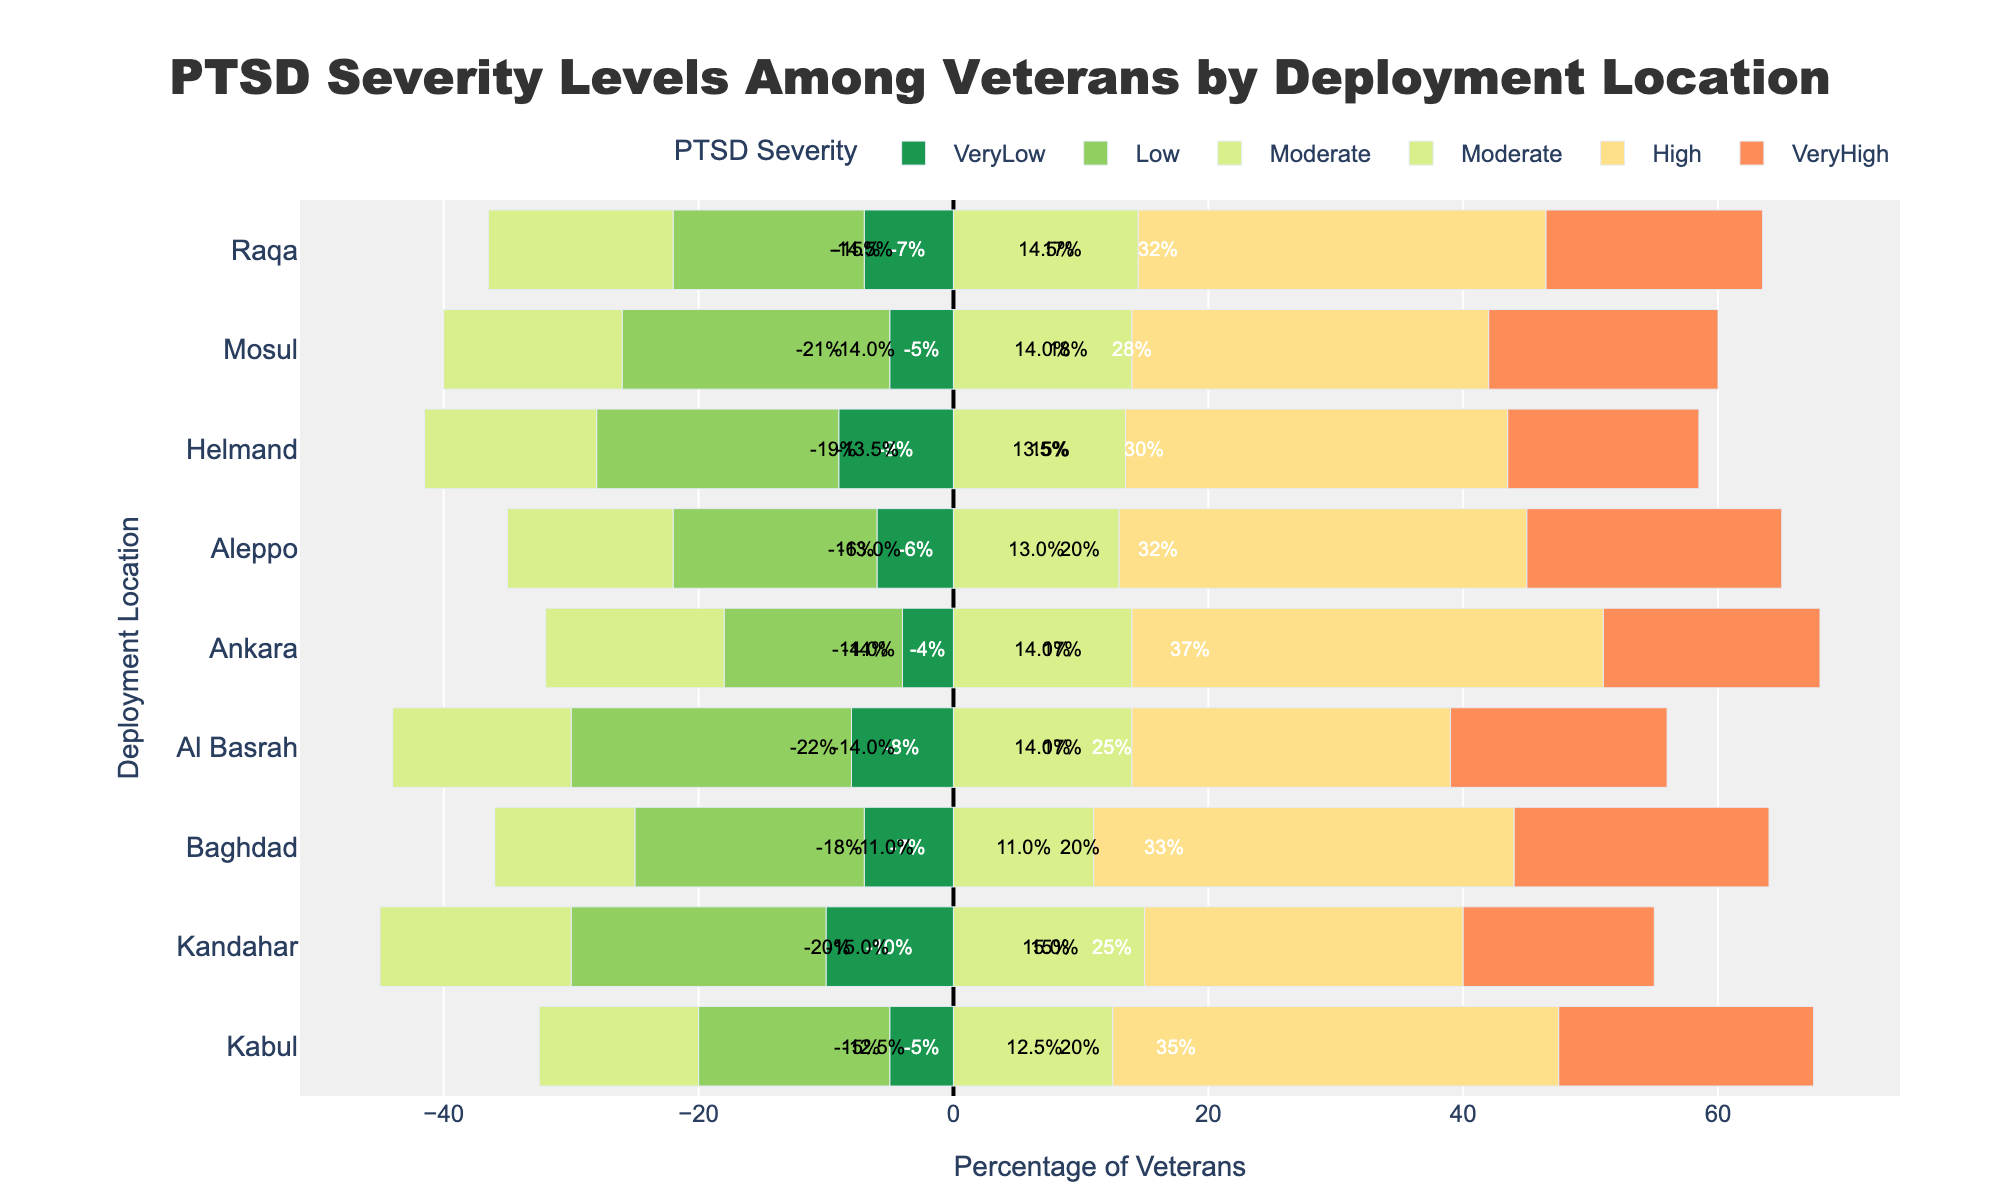What deployment location shows the highest percentage of veterans with very high PTSD severity? To determine this, look for the longest bar segment labeled "Very High" (in red) and identify the corresponding deployment location.
Answer: Kabul Which location has more veterans with moderate PTSD severity: Kandahar or Aleppo? Compare the lengths of the orange segments representing "Moderate" for Kandahar and Aleppo. Kandahar's segment is longer.
Answer: Kandahar What is the total percentage of veterans with low and moderate PTSD severity in Raqa? Add the values of the segments labeled "Low" (green) and "Moderate" (yellow) for Raqa: 15% (Low) + 29% (Moderate).
Answer: 44% Between Baghdad and Al Basrah, which location has fewer veterans with very low and very high PTSD severity combined? Sum the segments labeled "Very Low" (green) and "Very High" (red) for both locations and compare. Baghdad: 7% (Very Low) + 20% (Very High) = 27%, Al Basrah: 8% (Very Low) + 17% (Very High) = 25%. Baghdad has fewer.
Answer: Al Basrah In which Syrian location is the percentage of veterans with high PTSD severity largest, and what is that percentage? Compare the length of the red bar segments labeled "High" for Ankara, Aleppo, and Raqa. Ankara has the longest bar.
Answer: 37% What is the mid-point value of the moderate PTSD severity in Helmand? Since the bars in the plot are already halved for overlap, look at the midpoint of the orange segment representing "Moderate." It's half of 27%.
Answer: 13.5% Are the percentages of veterans with low PTSD severity in Kabul and Baghdad equal? Check the length of the green segments for both Kabul and Baghdad representing "Low." Both are 18%.
Answer: Yes How does the percentage of veterans with very low PTSD severity in Mosul compare to Helmand? Look at the lengths of the green segments labeled "Very Low" for Mosul and Helmand. Mosul has 5% and Helmand has 9%. Mosul has a lower percentage.
Answer: Lower What is the total percentage of veterans with high or very high PTSD severity in Baghdad? Add the percentages of the segments labeled "High" (orange) and "Very High" (red) for Baghdad: 33% (High) + 20% (Very High).
Answer: 53% Which location shows the most balanced distribution of PTSD severity levels? Identify the location where the bars are closest in length across all severity levels. Both Raqa and Al Basrah show relatively balanced distributions, but Raqa is slightly more balanced.
Answer: Raqa 